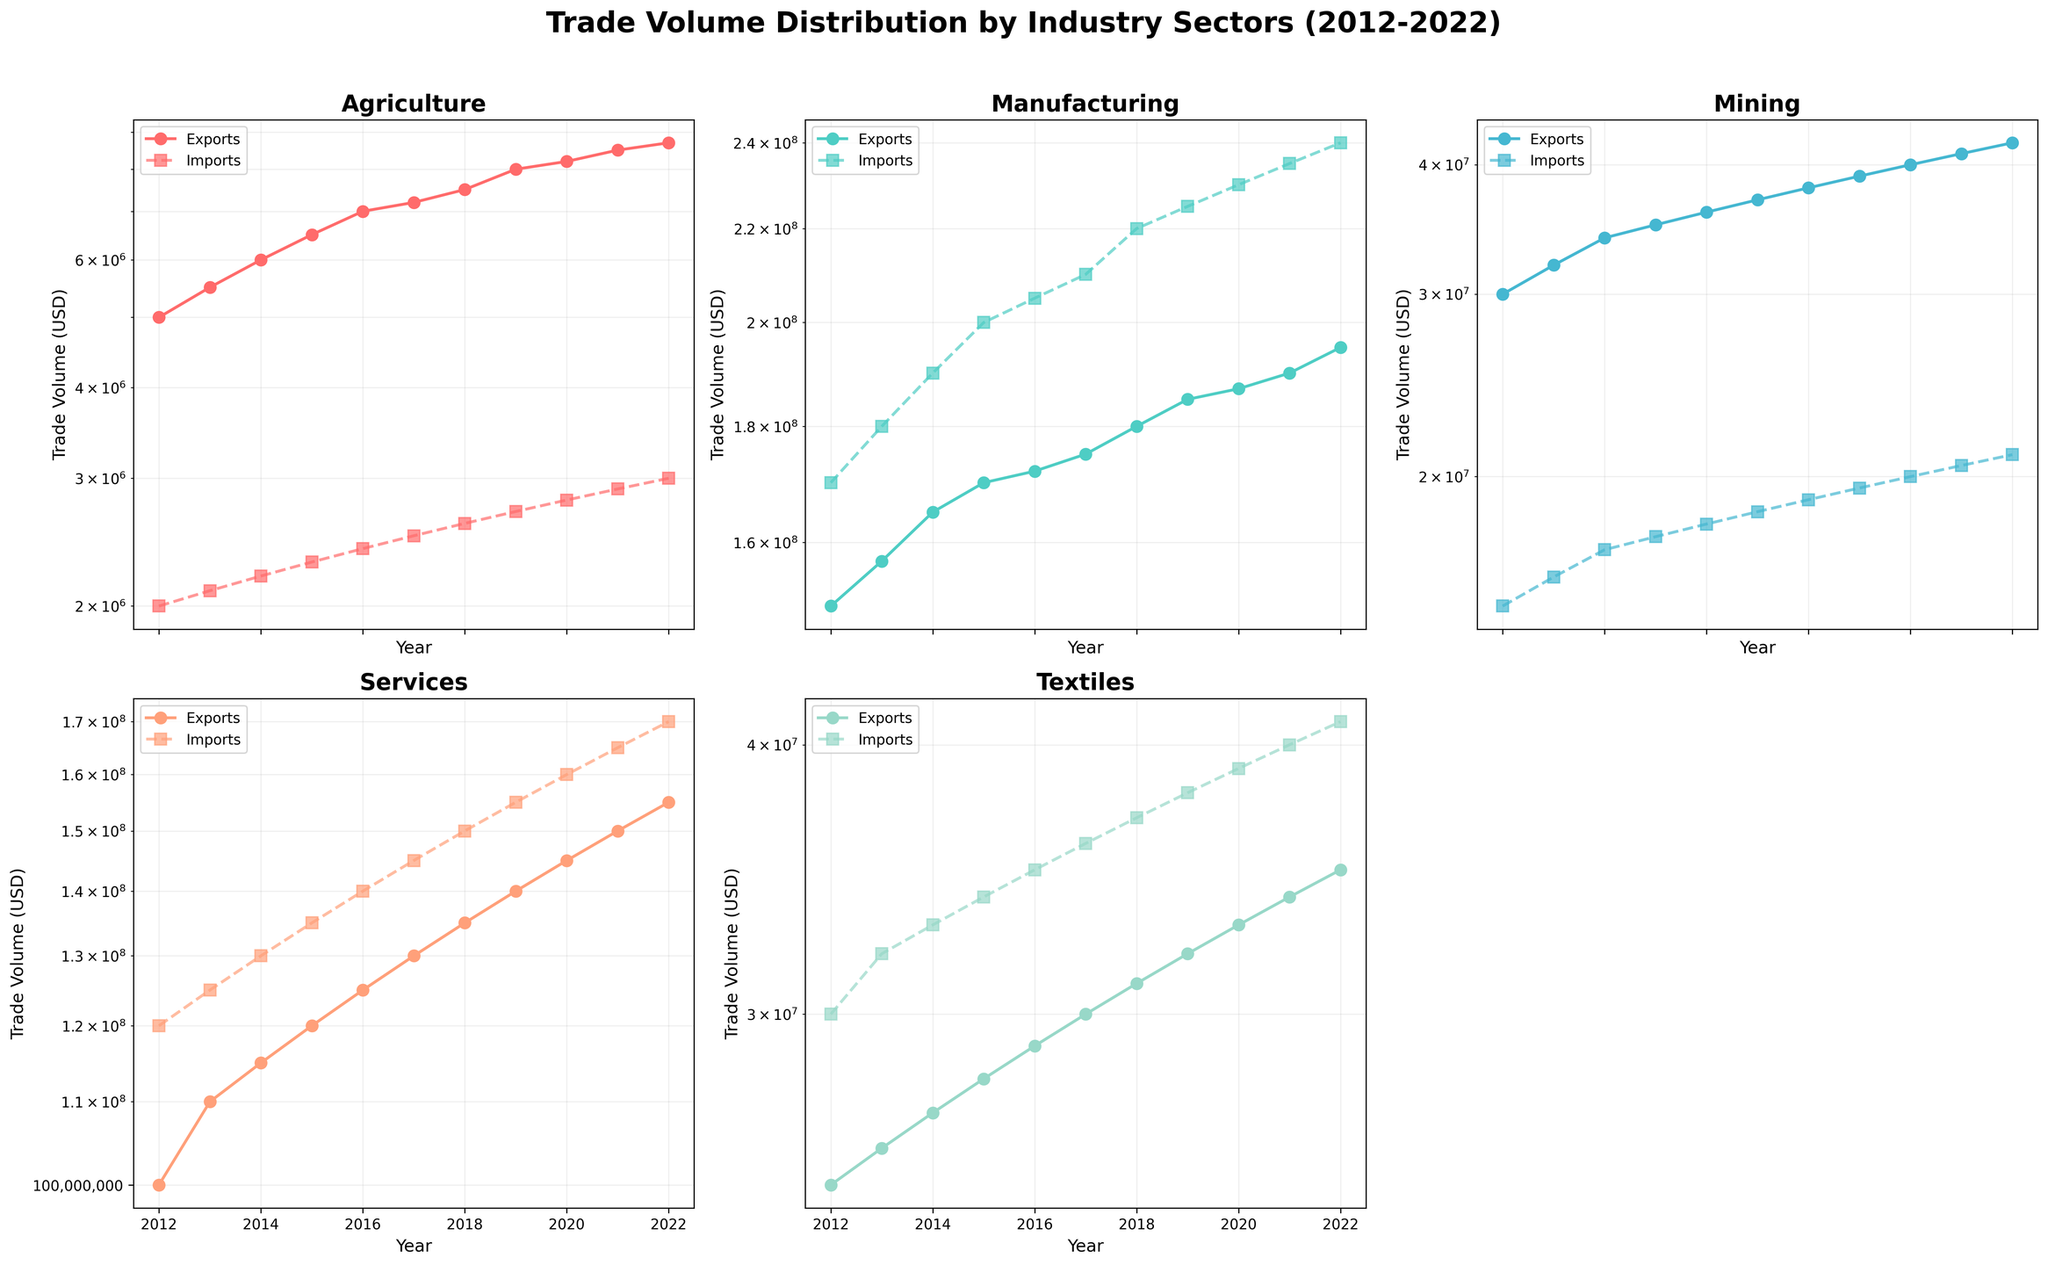Which industry has the highest export volume for most of the years? By looking at the subplots, the Manufacturing industry consistently shows the highest export volumes across the years compared to other industries.
Answer: Manufacturing What is the title of the figure? The title is positioned at the top of the figure. It reads "Trade Volume Distribution by Industry Sectors (2012-2022)".
Answer: Trade Volume Distribution by Industry Sectors (2012-2022) Between which years did the Services industry see the most significant increase in import volume? By examining the Services subplot, we see the steepest increase in import volume from 2015 to 2016.
Answer: 2015 to 2016 How many times in total does the Agriculture industry subplot change markers? The Agriculture industry uses different markers for exports (circles) and imports (squares). This industry appears in the first subplot, which shows different markers for each trade type but remains consistent for the entire period.
Answer: 2 Which industry showed a sharp decline in export volume during the entire decade? Observing all subplots, there is no industry with a sharp decline in export volume over the given decade; all industries show either growth or fluctuation at the same levels.
Answer: None In which years does the Mining industry have its export volume surpassing imports? The Mining industry generally shows its exports surpassing imports in all plotted years. This can be identified by comparing the export and import lines in the Mining subplot.
Answer: All years What industry experienced the smallest gap between export and import volumes in 2022? By examining the end year on each subplot (2022), the smallest gap between exports and imports appears in the Textiles industry.
Answer: Textiles How does the general trend of export volume in the Services industry compare to that of the Textiles industry? Observing both Services and Textiles subplots, the Services industry exports show a general increasing trend while Textiles exports also increase but at a slower rate.
Answer: Services increase more Compare the export volumes of Agriculture in 2012 and 2022. What is the percent increase? The Agriculture export volumes are 5,000,000 in 2012 and 8,700,000 in 2022. Calculating the percent increase: ((8,700,000 - 5,000,000) / 5,000,000) * 100 = 74%
Answer: 74% Which industry has consistently higher import volumes than export volumes throughout the decade? Checking all subplots, the Manufacturing industry shows consistently higher import volumes compared to export volumes in every year.
Answer: Manufacturing 